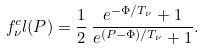Convert formula to latex. <formula><loc_0><loc_0><loc_500><loc_500>f _ { \nu } ^ { c } l ( P ) = \frac { 1 } { 2 } \, \frac { e ^ { - \Phi / T _ { \nu } } + 1 } { e ^ { ( P - \Phi ) / T _ { \nu } } + 1 } .</formula> 